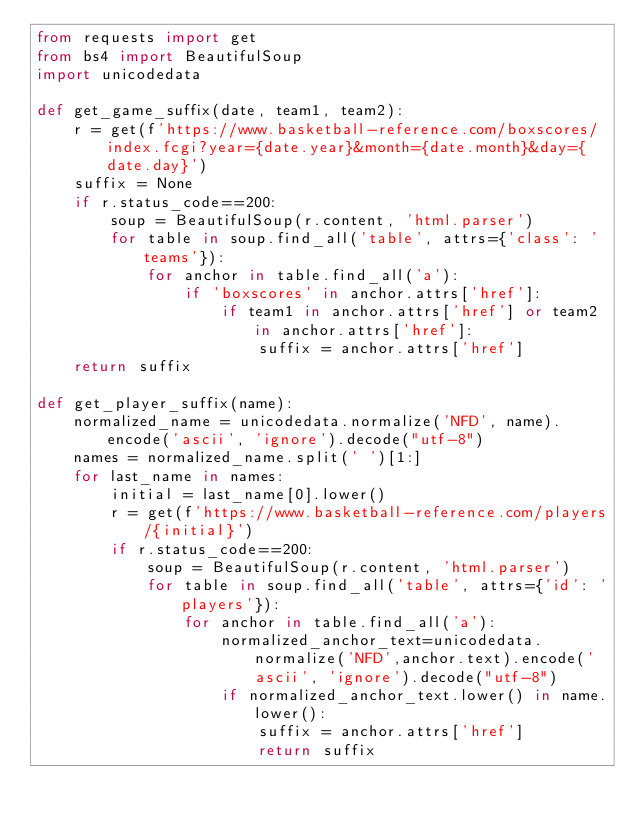Convert code to text. <code><loc_0><loc_0><loc_500><loc_500><_Python_>from requests import get
from bs4 import BeautifulSoup
import unicodedata

def get_game_suffix(date, team1, team2):
    r = get(f'https://www.basketball-reference.com/boxscores/index.fcgi?year={date.year}&month={date.month}&day={date.day}')
    suffix = None
    if r.status_code==200:
        soup = BeautifulSoup(r.content, 'html.parser')
        for table in soup.find_all('table', attrs={'class': 'teams'}):
            for anchor in table.find_all('a'):
                if 'boxscores' in anchor.attrs['href']:
                    if team1 in anchor.attrs['href'] or team2 in anchor.attrs['href']:
                        suffix = anchor.attrs['href']
    return suffix

def get_player_suffix(name):
    normalized_name = unicodedata.normalize('NFD', name).encode('ascii', 'ignore').decode("utf-8")
    names = normalized_name.split(' ')[1:]
    for last_name in names:
        initial = last_name[0].lower()
        r = get(f'https://www.basketball-reference.com/players/{initial}')
        if r.status_code==200:
            soup = BeautifulSoup(r.content, 'html.parser')
            for table in soup.find_all('table', attrs={'id': 'players'}):
                for anchor in table.find_all('a'):
                    normalized_anchor_text=unicodedata.normalize('NFD',anchor.text).encode('ascii', 'ignore').decode("utf-8")
                    if normalized_anchor_text.lower() in name.lower():
                        suffix = anchor.attrs['href']
                        return suffix
</code> 